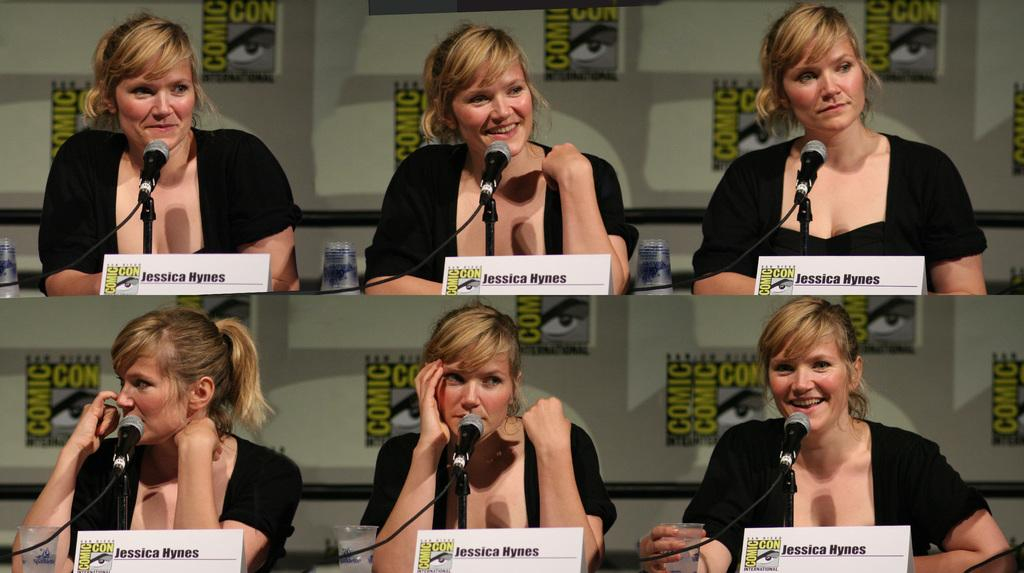What is the main subject of the image? The main subject of the image is a woman with different expressions. How is the image presented? The image is a collage of two images. What objects are present in the image related to communication? There are name boards and microphones in the image. What can be seen on the table in the image? There are glasses on the table in the image. What type of slope can be seen in the image? There is no slope present in the image. What is the woman doing at the meeting in the image? The image does not depict a meeting, and there is no indication of the woman's activity related to a meeting. 